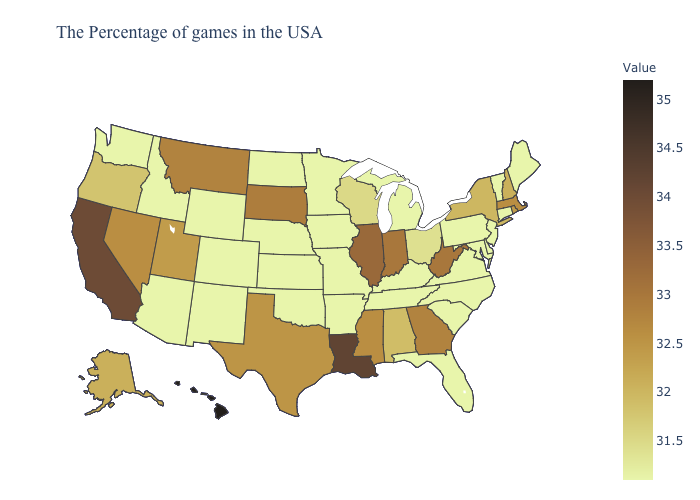Does the map have missing data?
Answer briefly. No. Does New Jersey have the lowest value in the Northeast?
Keep it brief. Yes. Does West Virginia have a higher value than California?
Short answer required. No. Does Louisiana have the highest value in the South?
Short answer required. Yes. Is the legend a continuous bar?
Give a very brief answer. Yes. 